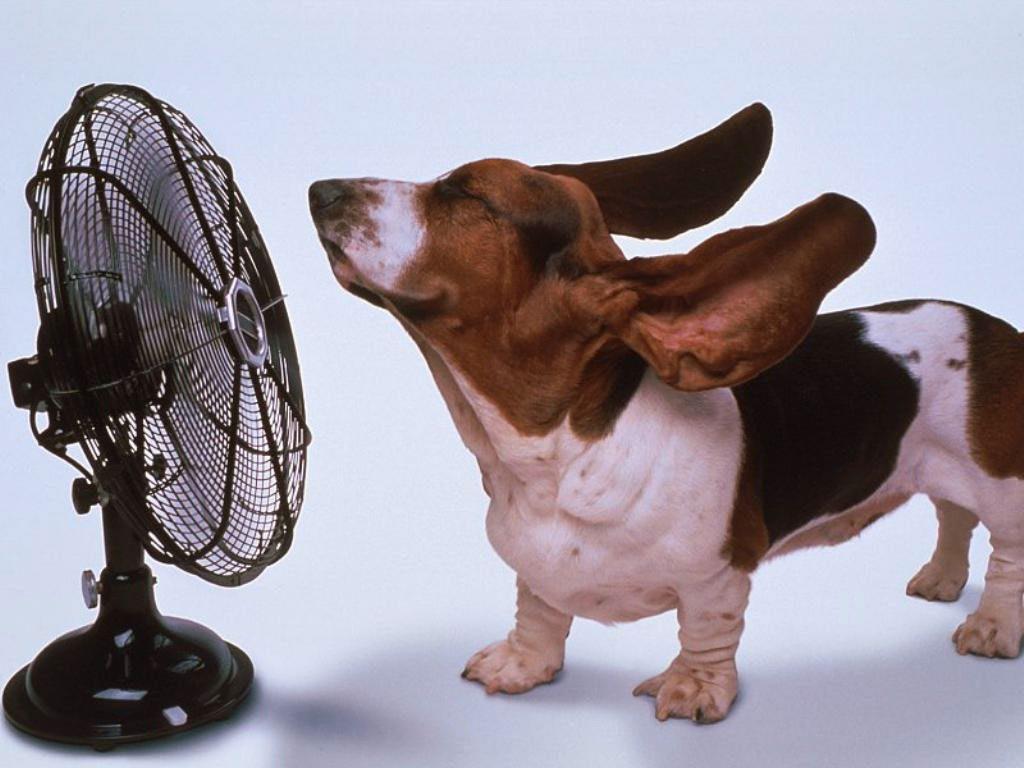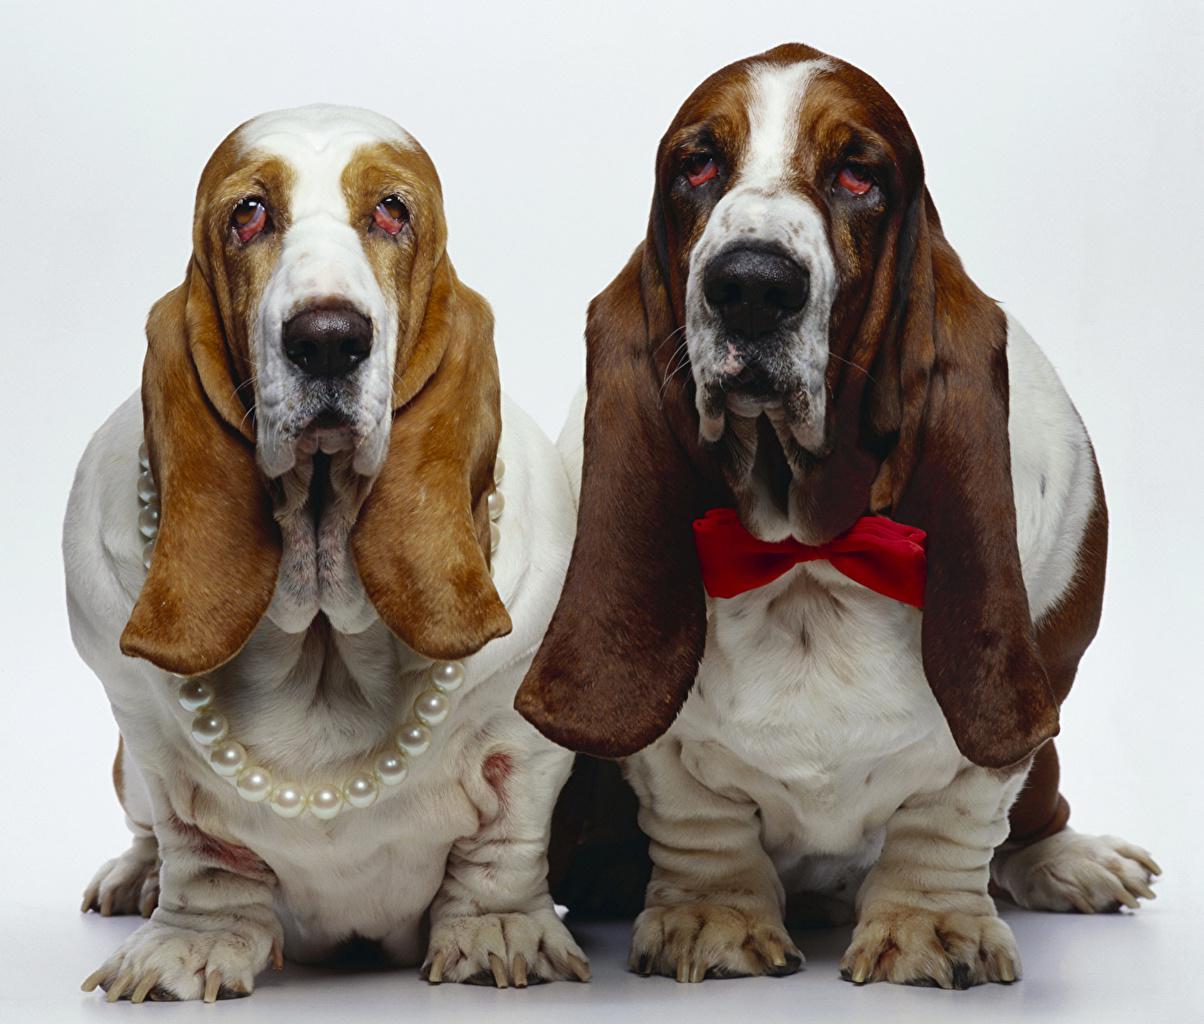The first image is the image on the left, the second image is the image on the right. Examine the images to the left and right. Is the description "The rear end of the dog in the image on the left is resting on the ground." accurate? Answer yes or no. No. The first image is the image on the left, the second image is the image on the right. Analyze the images presented: Is the assertion "Each image contains only one dog, and one image shows a basset hound standing in profile on a white background." valid? Answer yes or no. No. 